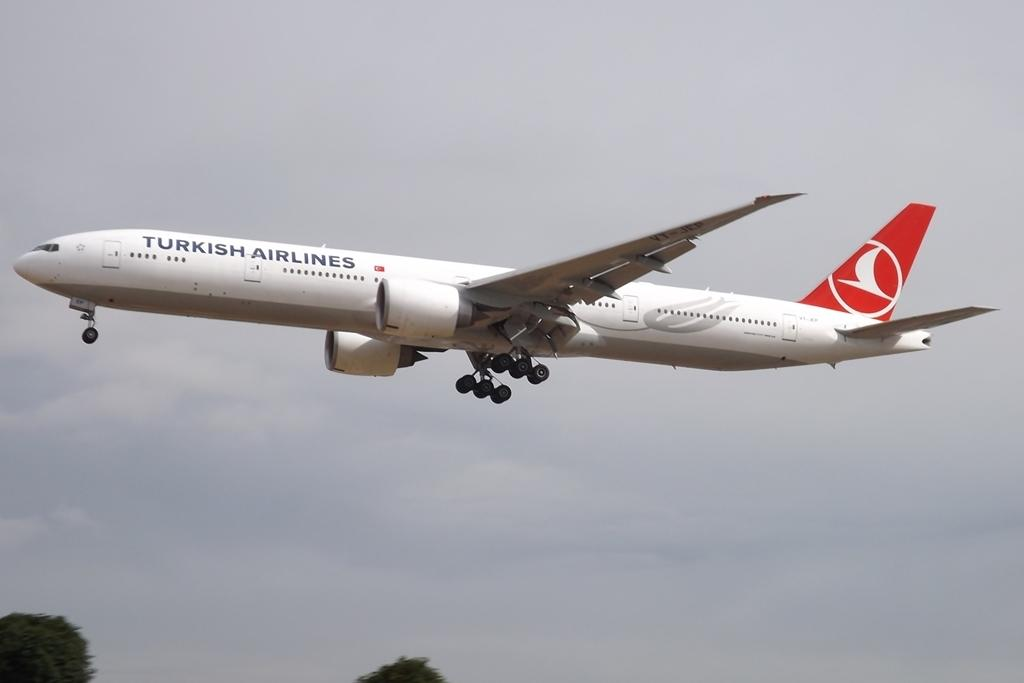<image>
Provide a brief description of the given image. A white turkish airlines airplane takes off and heads into the sky. 